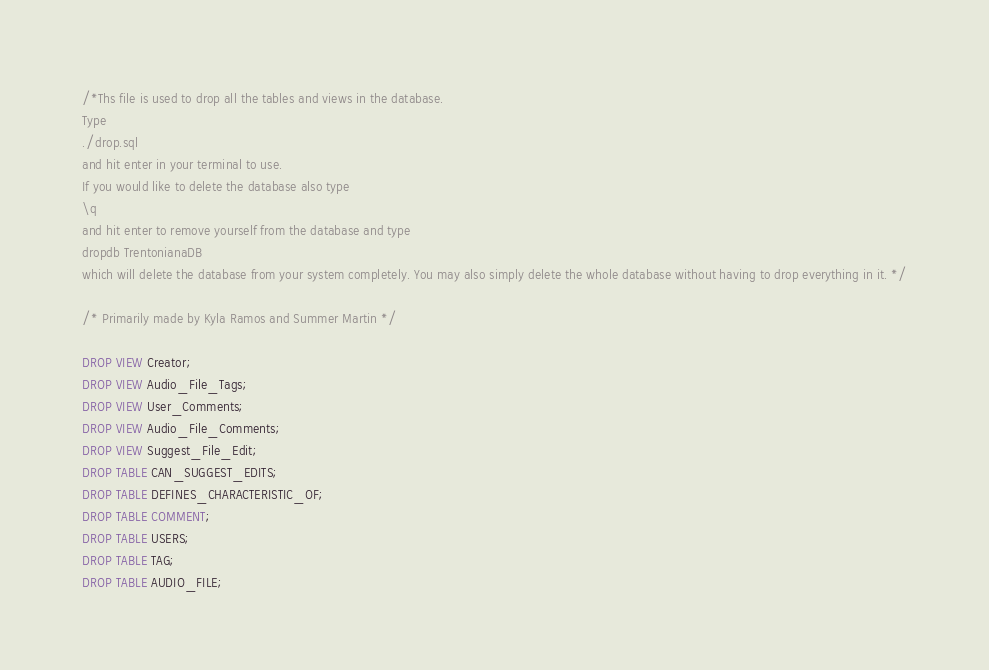<code> <loc_0><loc_0><loc_500><loc_500><_SQL_>/*Ths file is used to drop all the tables and views in the database.
Type
./drop.sql 
and hit enter in your terminal to use. 
If you would like to delete the database also type 
\q 
and hit enter to remove yourself from the database and type
dropdb TrentonianaDB
which will delete the database from your system completely. You may also simply delete the whole database without having to drop everything in it. */

/* Primarily made by Kyla Ramos and Summer Martin */

DROP VIEW Creator;
DROP VIEW Audio_File_Tags;
DROP VIEW User_Comments;
DROP VIEW Audio_File_Comments;
DROP VIEW Suggest_File_Edit;
DROP TABLE CAN_SUGGEST_EDITS;
DROP TABLE DEFINES_CHARACTERISTIC_OF;
DROP TABLE COMMENT;
DROP TABLE USERS;
DROP TABLE TAG;
DROP TABLE AUDIO_FILE;
</code> 